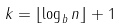<formula> <loc_0><loc_0><loc_500><loc_500>k = \lfloor \log _ { b } { n } \rfloor + 1</formula> 